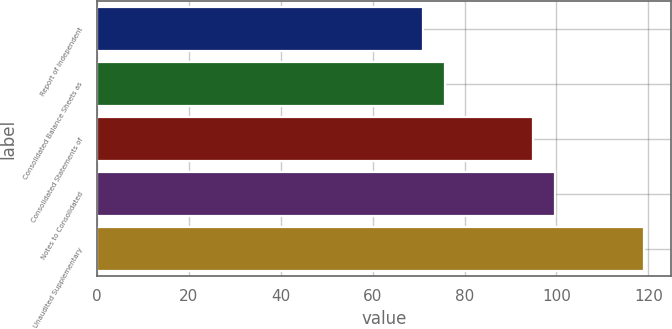<chart> <loc_0><loc_0><loc_500><loc_500><bar_chart><fcel>Report of Independent<fcel>Consolidated Balance Sheets as<fcel>Consolidated Statements of<fcel>Notes to Consolidated<fcel>Unaudited Supplementary<nl><fcel>71<fcel>75.8<fcel>95<fcel>99.8<fcel>119<nl></chart> 